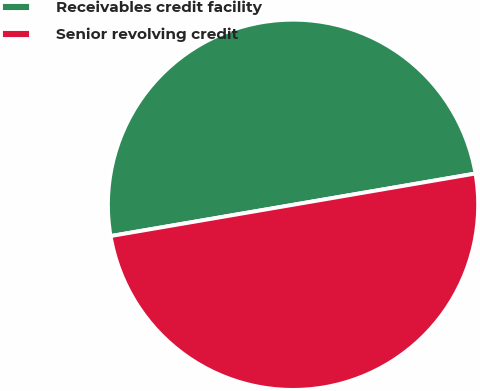Convert chart to OTSL. <chart><loc_0><loc_0><loc_500><loc_500><pie_chart><fcel>Receivables credit facility<fcel>Senior revolving credit<nl><fcel>50.0%<fcel>50.0%<nl></chart> 